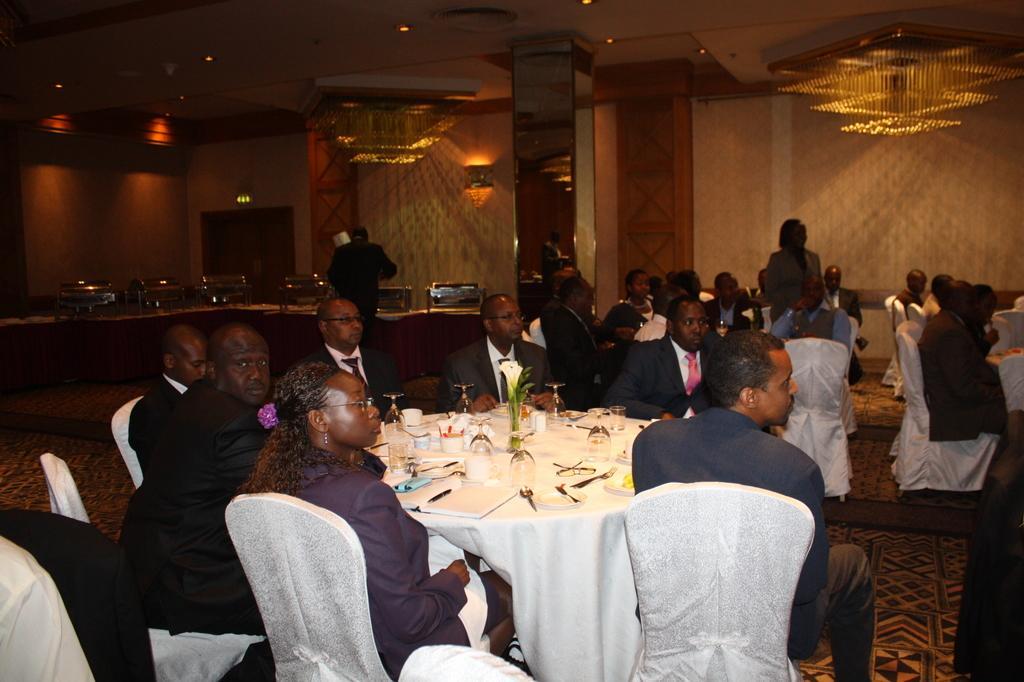Describe this image in one or two sentences. In this picture there are group of people sitting on the left side in the chairs and group of people sitting on the right side of the chairs and in the table there is book, pen , glass ,tissues , and a flower and at the back ground there is a door and chandelier fixed to the wall. 